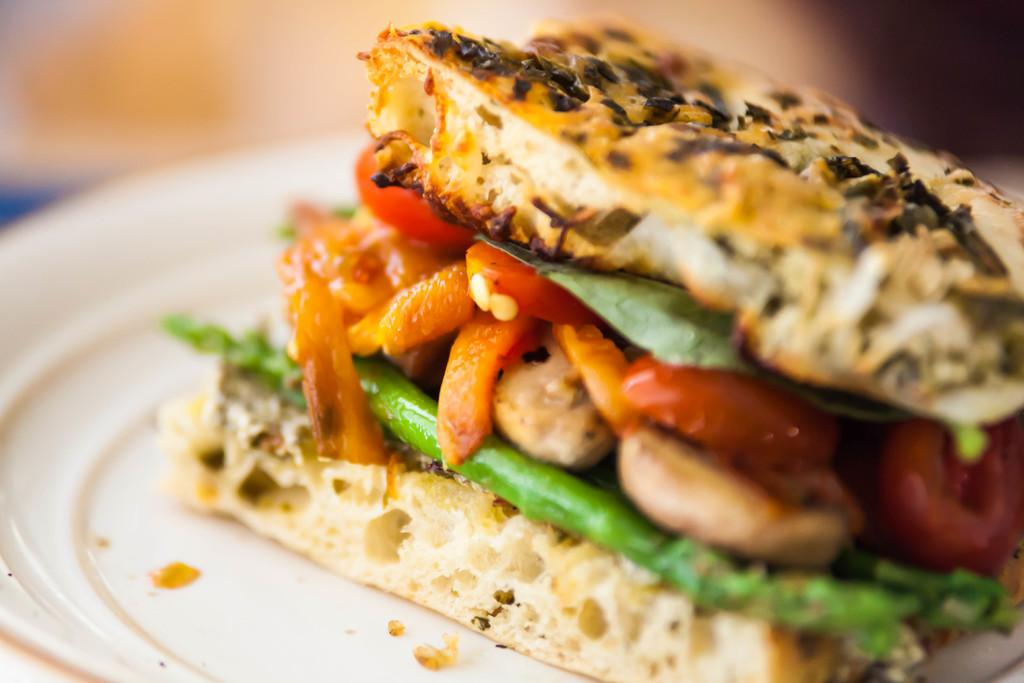What type of food can be seen in the image? There is food in the image, and it appears to be a burger. What colors are present in the food? The food is in brown, orange, green, and red colors. How is the background of the image depicted? The background of the image is blurred. How much pain is the burger experiencing in the image? The burger is not a living being and therefore cannot experience pain. The image is a still representation of a burger, not a depiction of its emotional state. 